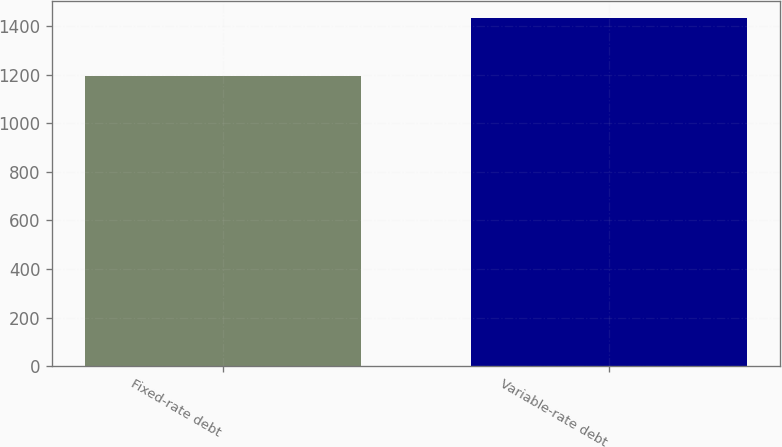<chart> <loc_0><loc_0><loc_500><loc_500><bar_chart><fcel>Fixed-rate debt<fcel>Variable-rate debt<nl><fcel>1196<fcel>1432<nl></chart> 